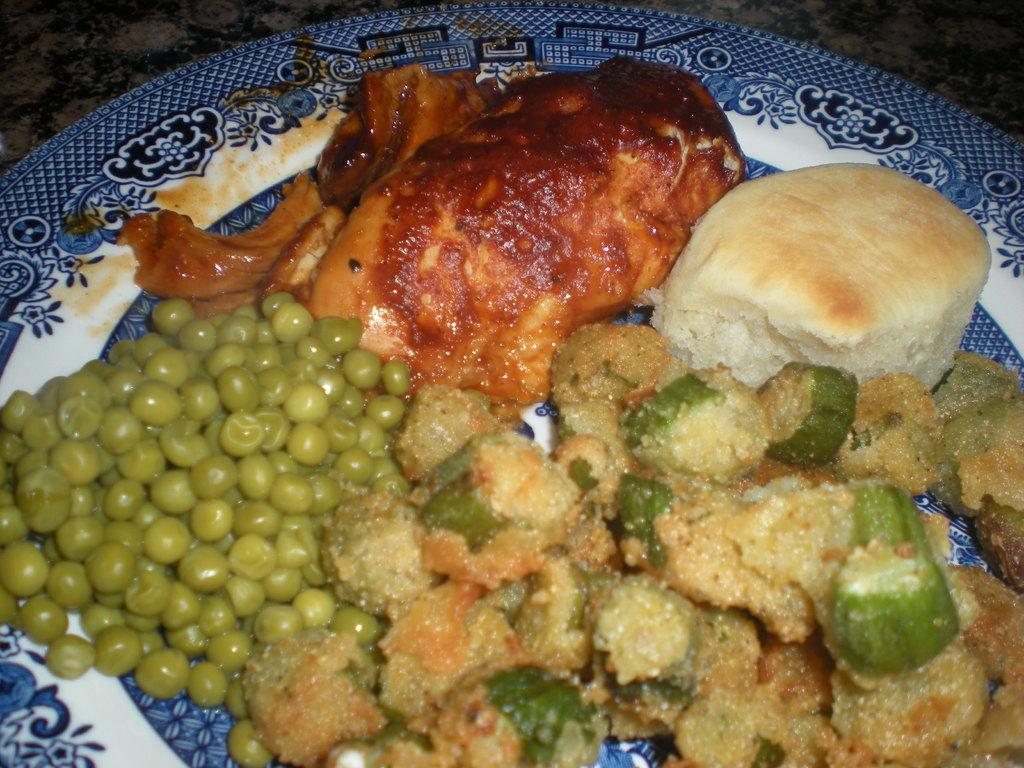Please provide a concise description of this image. In the image there is a meat,bread,beans and veg curry in a plate. 